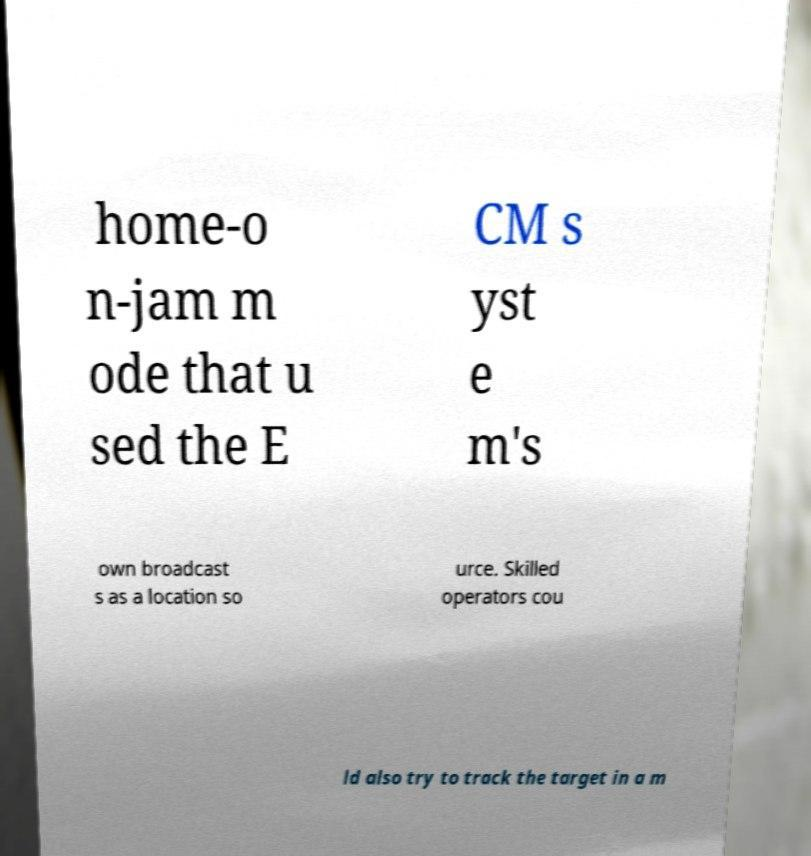Could you extract and type out the text from this image? home-o n-jam m ode that u sed the E CM s yst e m's own broadcast s as a location so urce. Skilled operators cou ld also try to track the target in a m 